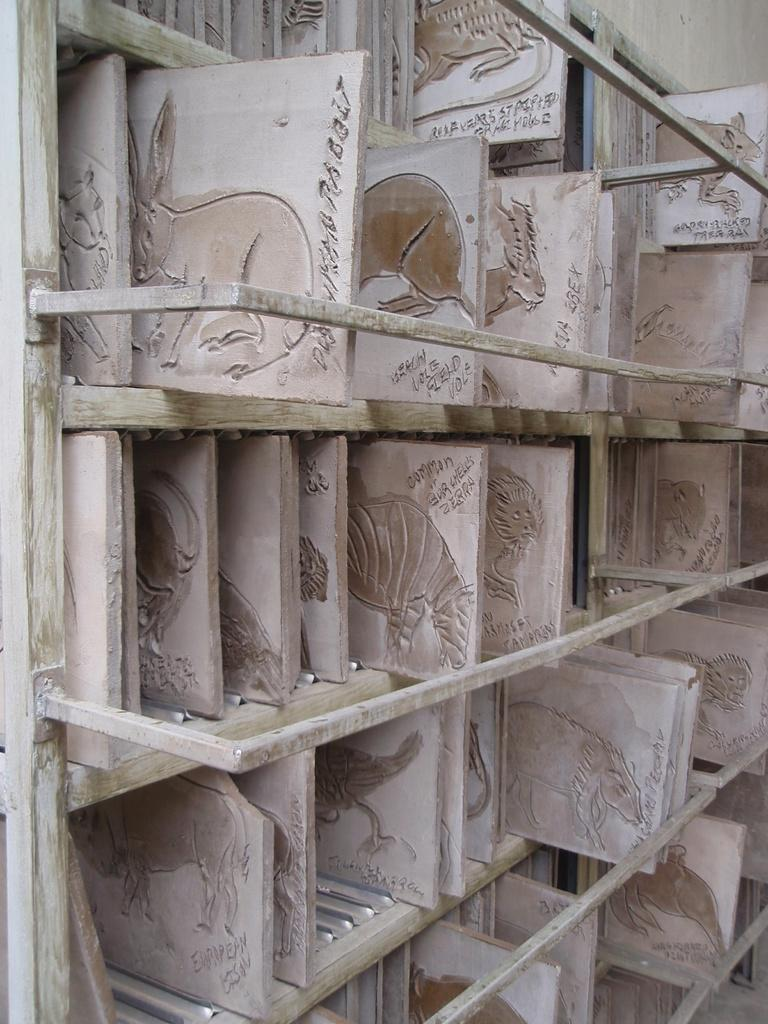What type of material is used to create the objects in the image? The objects in the image are made of blocks of wood. How are the blocks of wood arranged in the image? The blocks of wood are arranged in shelves. What type of elbow can be seen in the image? There is no elbow present in the image. 